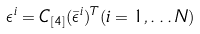<formula> <loc_0><loc_0><loc_500><loc_500>\epsilon ^ { i } = C _ { [ 4 ] } ( \bar { \epsilon } ^ { i } ) ^ { T } ( i = 1 , \dots N )</formula> 